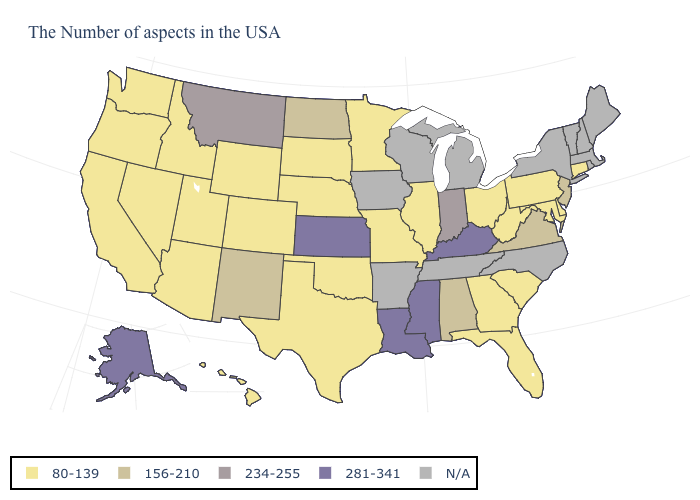What is the lowest value in the South?
Write a very short answer. 80-139. Which states hav the highest value in the West?
Give a very brief answer. Alaska. What is the value of Indiana?
Be succinct. 234-255. What is the highest value in the USA?
Give a very brief answer. 281-341. Name the states that have a value in the range 281-341?
Answer briefly. Kentucky, Mississippi, Louisiana, Kansas, Alaska. What is the highest value in the MidWest ?
Quick response, please. 281-341. Name the states that have a value in the range 234-255?
Write a very short answer. Indiana, Montana. Name the states that have a value in the range 156-210?
Give a very brief answer. New Jersey, Virginia, Alabama, North Dakota, New Mexico. What is the lowest value in states that border Maryland?
Short answer required. 80-139. Name the states that have a value in the range 281-341?
Give a very brief answer. Kentucky, Mississippi, Louisiana, Kansas, Alaska. Name the states that have a value in the range 156-210?
Concise answer only. New Jersey, Virginia, Alabama, North Dakota, New Mexico. Name the states that have a value in the range 234-255?
Write a very short answer. Indiana, Montana. Which states have the highest value in the USA?
Concise answer only. Kentucky, Mississippi, Louisiana, Kansas, Alaska. What is the value of Colorado?
Concise answer only. 80-139. 